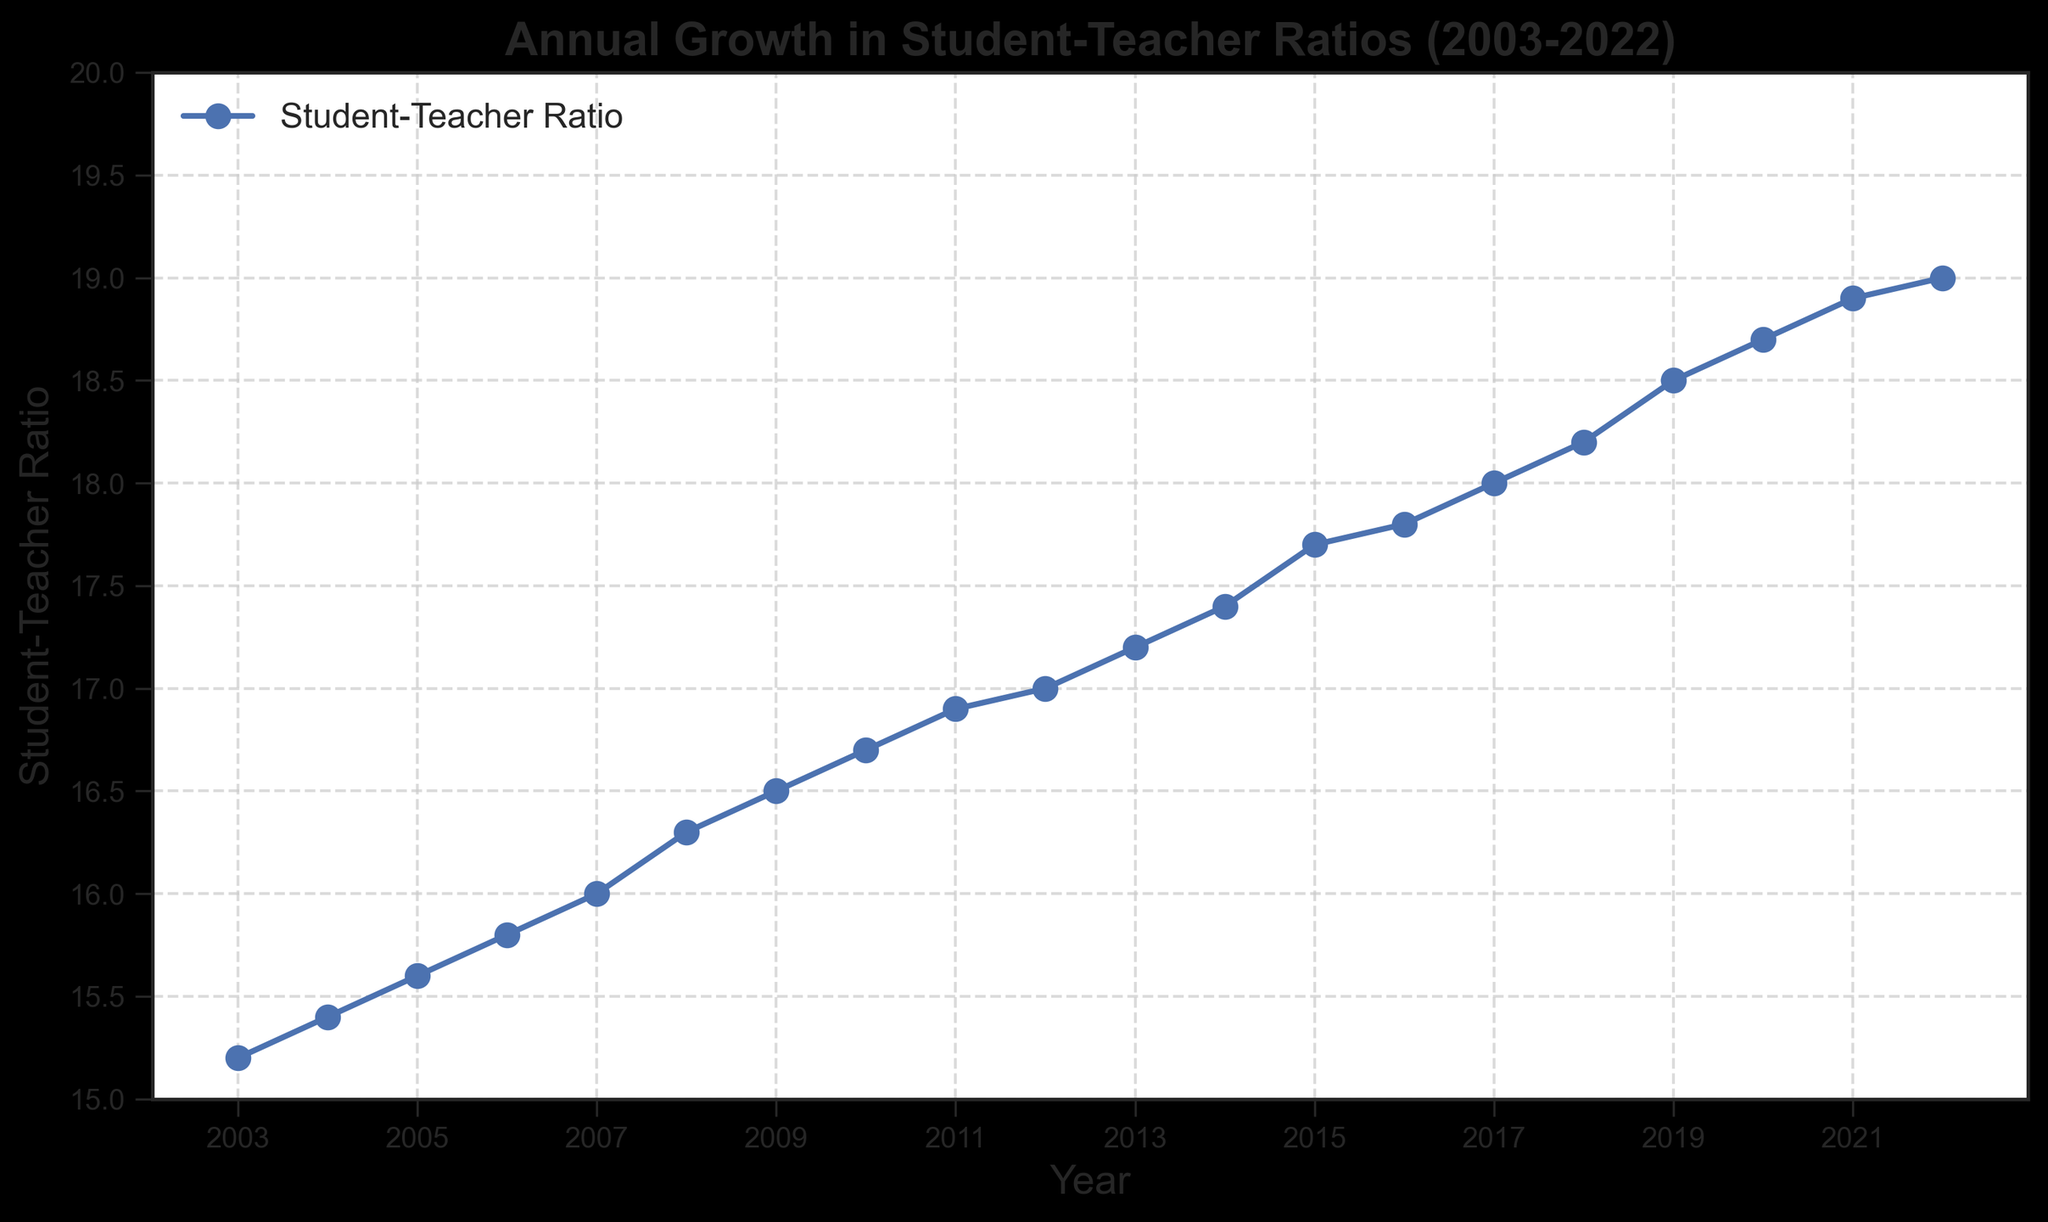What is the student-teacher ratio in 2011? To find the student-teacher ratio for 2011, locate the year 2011 on the x-axis and read the corresponding value on the y-axis.
Answer: 16.9 Which year shows the highest student-teacher ratio? To determine the year with the highest student-teacher ratio, scan the line plot for the highest point on the graph, then read the corresponding year on the x-axis.
Answer: 2022 What is the difference in student-teacher ratios between 2005 and 2015? First, find the student-teacher ratios for the years 2005 and 2015. The ratio for 2005 is 15.6 and for 2015 is 17.7. Subtract the ratio from 2005 from the ratio from 2015: 17.7 - 15.6.
Answer: 2.1 What is the average student-teacher ratio from 2003 to 2007? To find the average, first add the ratios from 2003 to 2007: 15.2 + 15.4 + 15.6 + 15.8 + 16.0 = 78. Then, divide by the number of years (5).
Answer: 15.6 Which year had a higher student-teacher ratio, 2008 or 2018? Compare the ratios for 2008 and 2018. For 2008, the ratio is 16.3, and for 2018, the ratio is 18.2. Since 18.2 is greater than 16.3, 2018 had a higher ratio.
Answer: 2018 By how much did the student-teacher ratio increase from 2008 to 2022? The student-teacher ratio in 2008 is 16.3 and in 2022 is 19.0. Subtract 16.3 from 19.0 to find the increase: 19.0 - 16.3.
Answer: 2.7 What is the trend of the student-teacher ratio from 2003 to 2022? Observe the overall direction of the line plot from 2003 to 2022. The line consistently rises, indicating an increasing trend over the years.
Answer: Increasing In which year did the student-teacher ratio first exceed 18? Find the first year on the x-axis where the y-axis value exceeds 18. This occurred in 2017 when the ratio became 18.0.
Answer: 2017 What is the median student-teacher ratio from 2003 to 2022? To find the median, list the student-teacher ratios in numerical order and find the middle value. Since there are 20 values, the median is the average of the 10th and 11th values: (17.0 + 17.2)/2.
Answer: 17.1 